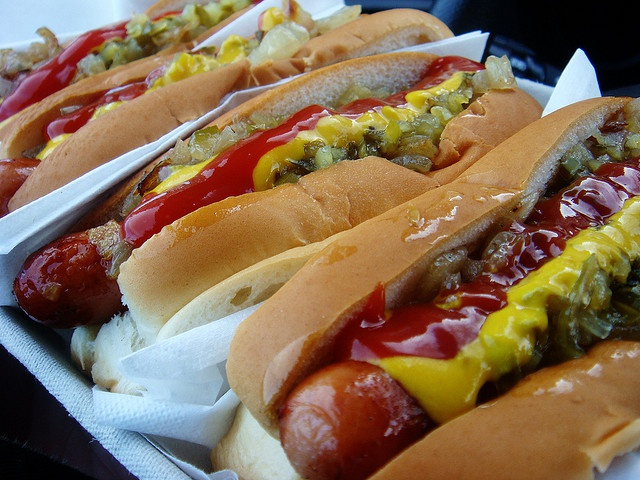Describe the objects in this image and their specific colors. I can see hot dog in lightblue, olive, maroon, tan, and black tones, hot dog in lightblue, olive, tan, gray, and maroon tones, hot dog in lightblue, tan, gray, and maroon tones, and hot dog in lightblue, darkgray, olive, and brown tones in this image. 